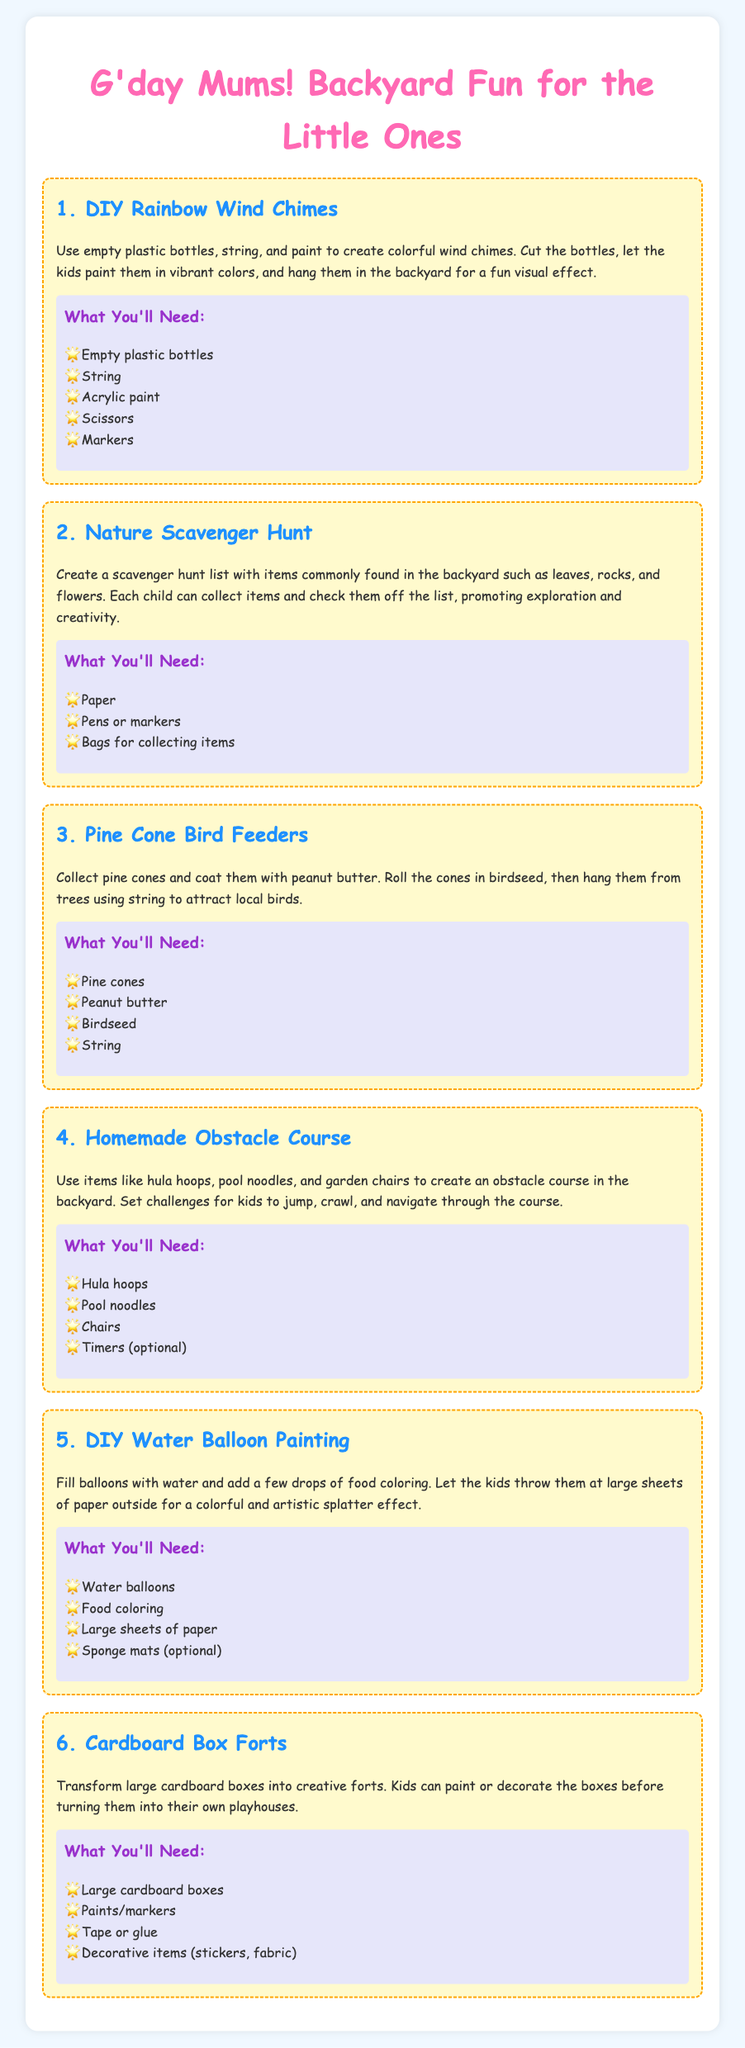What is the title of the document? The title is found in the header of the document, which states the main theme and purpose.
Answer: Fun Backyard Activities for Kids What is one material needed for DIY Rainbow Wind Chimes? This information can be found in the materials section of each activity.
Answer: Empty plastic bottles How many activities are listed in the document? The number of activities can be counted from the different sections in the document.
Answer: Six What is the main purpose of the Nature Scavenger Hunt? The purpose is described in the explanation of the activity, focusing on children's engagement.
Answer: Exploration and creativity Which activity involves water balloons? This is specified in the title of the respective section in the document.
Answer: DIY Water Balloon Painting What can be used to create an obstacle course? The materials listed in the description give insight into potential items used.
Answer: Hula hoops, pool noodles, and chairs How do you attract birds in the Pine Cone Bird Feeders activity? The method is shared in the activity description, detailing the steps to complete the task.
Answer: Hang them from trees What item is optional for DIY Water Balloon Painting? This choice is mentioned in the materials list of the corresponding activity.
Answer: Sponge mats What decorative materials can be used for Cardboard Box Forts? This information is found in the materials needed for constructing the forts.
Answer: Stickers, fabric 